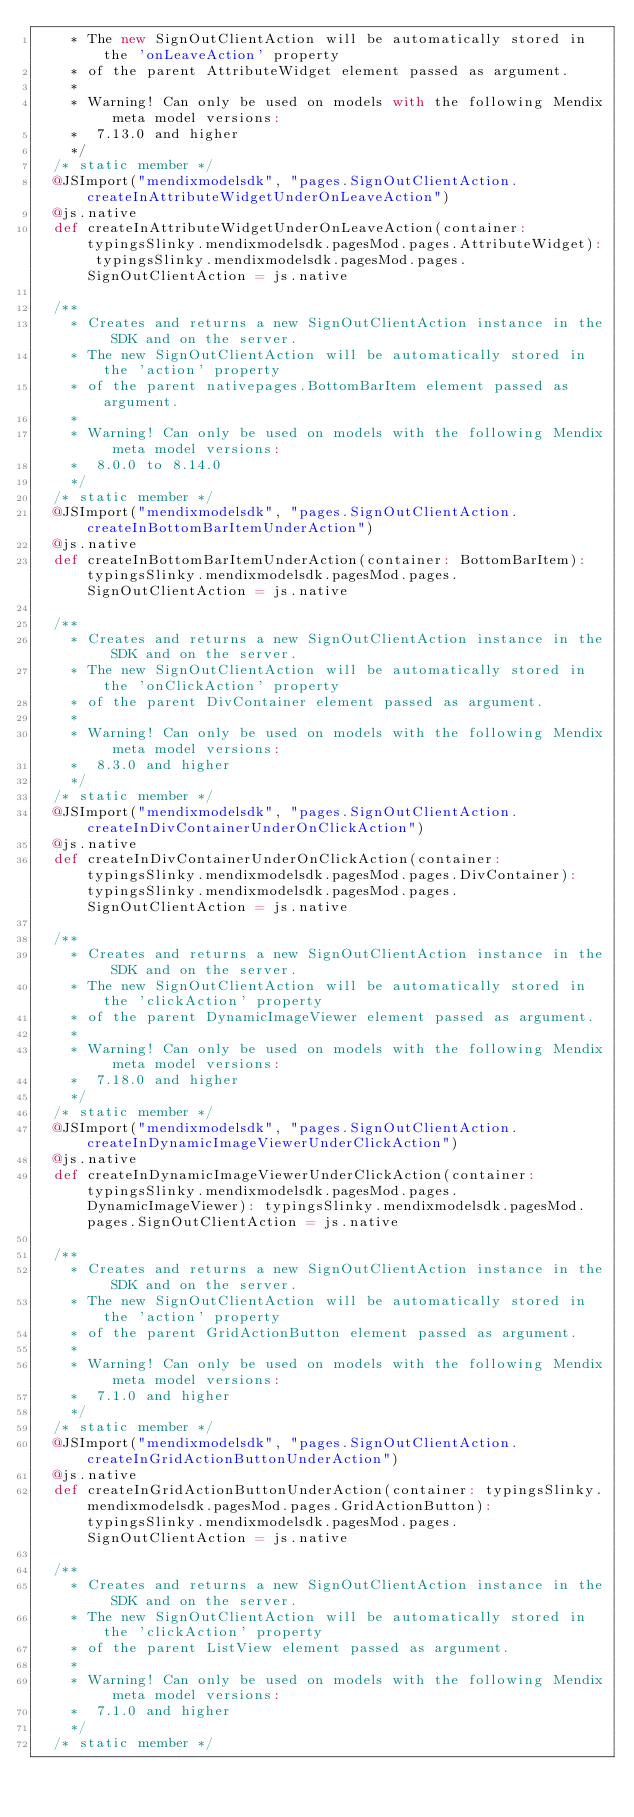Convert code to text. <code><loc_0><loc_0><loc_500><loc_500><_Scala_>    * The new SignOutClientAction will be automatically stored in the 'onLeaveAction' property
    * of the parent AttributeWidget element passed as argument.
    *
    * Warning! Can only be used on models with the following Mendix meta model versions:
    *  7.13.0 and higher
    */
  /* static member */
  @JSImport("mendixmodelsdk", "pages.SignOutClientAction.createInAttributeWidgetUnderOnLeaveAction")
  @js.native
  def createInAttributeWidgetUnderOnLeaveAction(container: typingsSlinky.mendixmodelsdk.pagesMod.pages.AttributeWidget): typingsSlinky.mendixmodelsdk.pagesMod.pages.SignOutClientAction = js.native
  
  /**
    * Creates and returns a new SignOutClientAction instance in the SDK and on the server.
    * The new SignOutClientAction will be automatically stored in the 'action' property
    * of the parent nativepages.BottomBarItem element passed as argument.
    *
    * Warning! Can only be used on models with the following Mendix meta model versions:
    *  8.0.0 to 8.14.0
    */
  /* static member */
  @JSImport("mendixmodelsdk", "pages.SignOutClientAction.createInBottomBarItemUnderAction")
  @js.native
  def createInBottomBarItemUnderAction(container: BottomBarItem): typingsSlinky.mendixmodelsdk.pagesMod.pages.SignOutClientAction = js.native
  
  /**
    * Creates and returns a new SignOutClientAction instance in the SDK and on the server.
    * The new SignOutClientAction will be automatically stored in the 'onClickAction' property
    * of the parent DivContainer element passed as argument.
    *
    * Warning! Can only be used on models with the following Mendix meta model versions:
    *  8.3.0 and higher
    */
  /* static member */
  @JSImport("mendixmodelsdk", "pages.SignOutClientAction.createInDivContainerUnderOnClickAction")
  @js.native
  def createInDivContainerUnderOnClickAction(container: typingsSlinky.mendixmodelsdk.pagesMod.pages.DivContainer): typingsSlinky.mendixmodelsdk.pagesMod.pages.SignOutClientAction = js.native
  
  /**
    * Creates and returns a new SignOutClientAction instance in the SDK and on the server.
    * The new SignOutClientAction will be automatically stored in the 'clickAction' property
    * of the parent DynamicImageViewer element passed as argument.
    *
    * Warning! Can only be used on models with the following Mendix meta model versions:
    *  7.18.0 and higher
    */
  /* static member */
  @JSImport("mendixmodelsdk", "pages.SignOutClientAction.createInDynamicImageViewerUnderClickAction")
  @js.native
  def createInDynamicImageViewerUnderClickAction(container: typingsSlinky.mendixmodelsdk.pagesMod.pages.DynamicImageViewer): typingsSlinky.mendixmodelsdk.pagesMod.pages.SignOutClientAction = js.native
  
  /**
    * Creates and returns a new SignOutClientAction instance in the SDK and on the server.
    * The new SignOutClientAction will be automatically stored in the 'action' property
    * of the parent GridActionButton element passed as argument.
    *
    * Warning! Can only be used on models with the following Mendix meta model versions:
    *  7.1.0 and higher
    */
  /* static member */
  @JSImport("mendixmodelsdk", "pages.SignOutClientAction.createInGridActionButtonUnderAction")
  @js.native
  def createInGridActionButtonUnderAction(container: typingsSlinky.mendixmodelsdk.pagesMod.pages.GridActionButton): typingsSlinky.mendixmodelsdk.pagesMod.pages.SignOutClientAction = js.native
  
  /**
    * Creates and returns a new SignOutClientAction instance in the SDK and on the server.
    * The new SignOutClientAction will be automatically stored in the 'clickAction' property
    * of the parent ListView element passed as argument.
    *
    * Warning! Can only be used on models with the following Mendix meta model versions:
    *  7.1.0 and higher
    */
  /* static member */</code> 